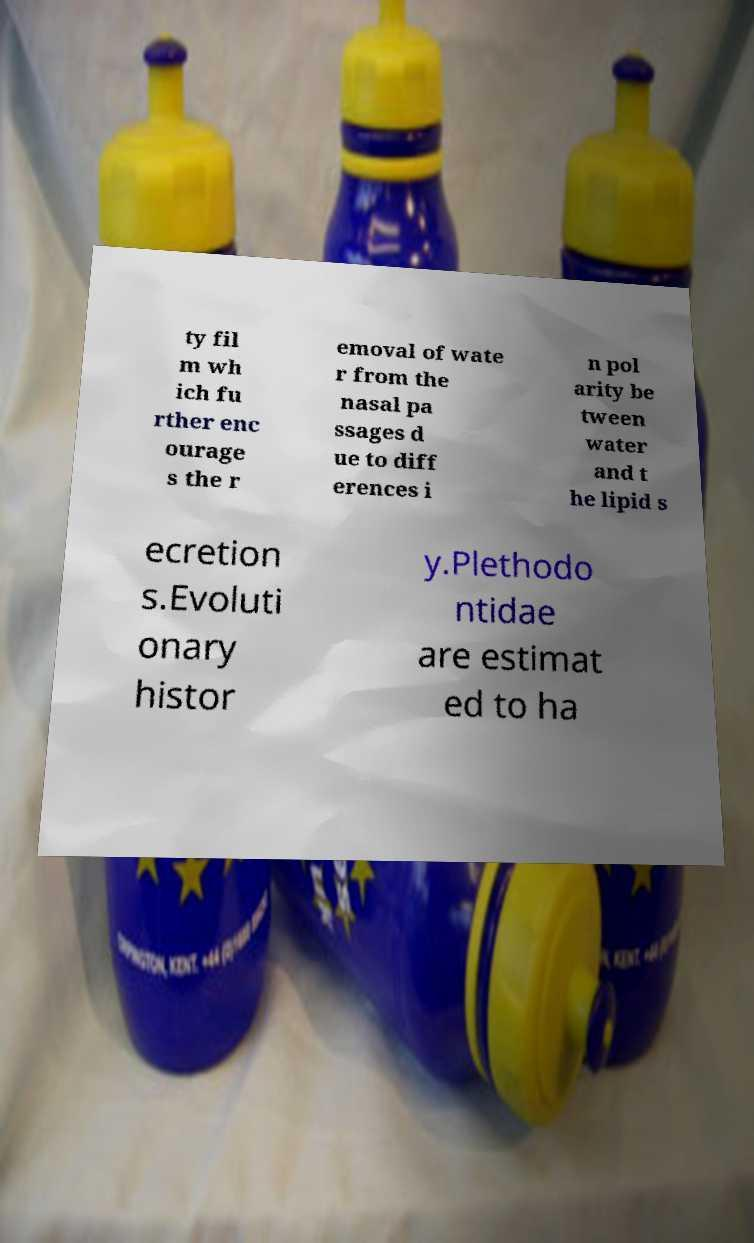Please read and relay the text visible in this image. What does it say? ty fil m wh ich fu rther enc ourage s the r emoval of wate r from the nasal pa ssages d ue to diff erences i n pol arity be tween water and t he lipid s ecretion s.Evoluti onary histor y.Plethodo ntidae are estimat ed to ha 